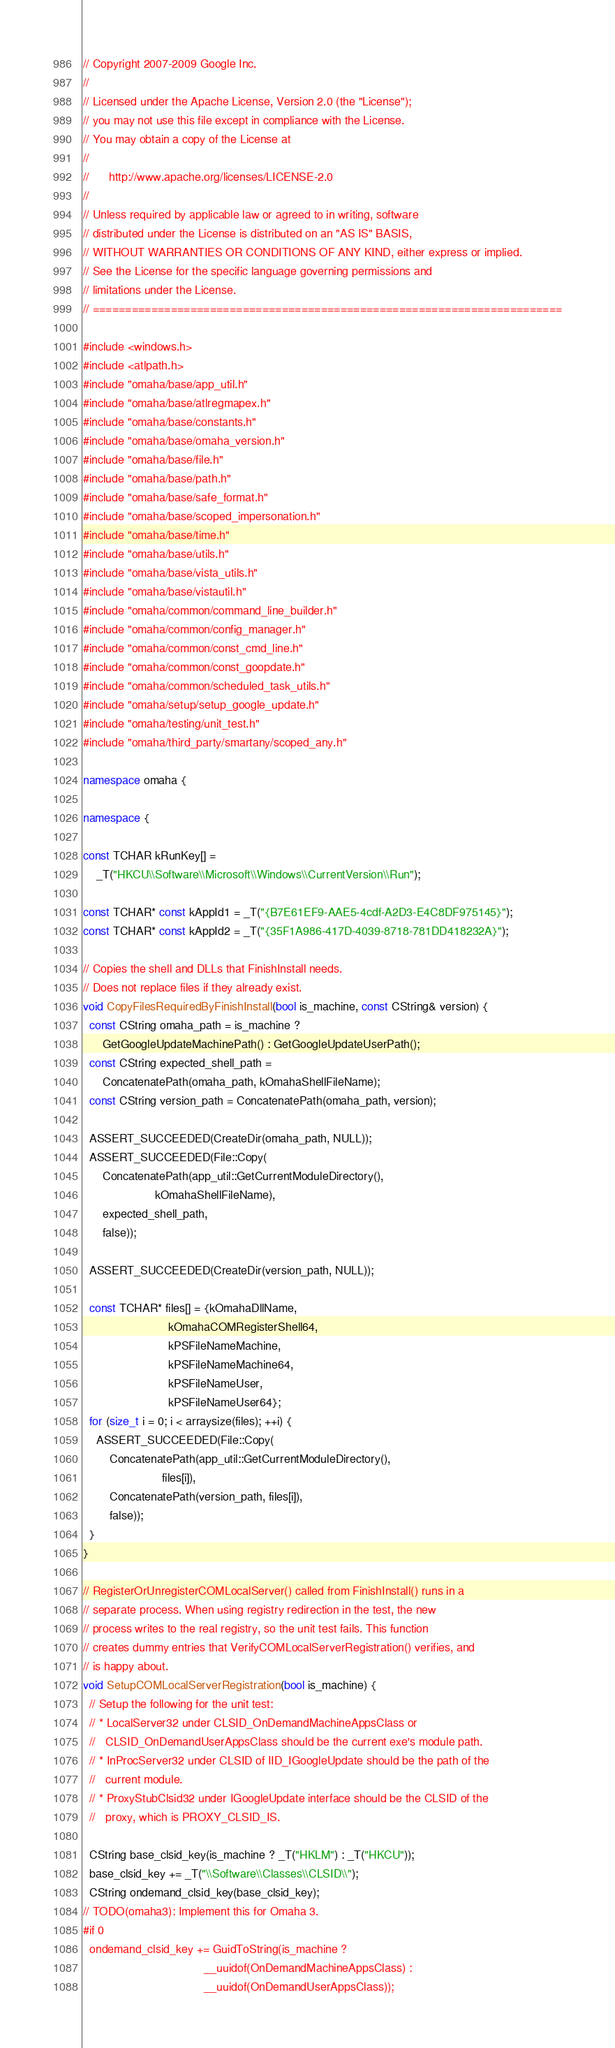<code> <loc_0><loc_0><loc_500><loc_500><_C++_>// Copyright 2007-2009 Google Inc.
//
// Licensed under the Apache License, Version 2.0 (the "License");
// you may not use this file except in compliance with the License.
// You may obtain a copy of the License at
//
//      http://www.apache.org/licenses/LICENSE-2.0
//
// Unless required by applicable law or agreed to in writing, software
// distributed under the License is distributed on an "AS IS" BASIS,
// WITHOUT WARRANTIES OR CONDITIONS OF ANY KIND, either express or implied.
// See the License for the specific language governing permissions and
// limitations under the License.
// ========================================================================

#include <windows.h>
#include <atlpath.h>
#include "omaha/base/app_util.h"
#include "omaha/base/atlregmapex.h"
#include "omaha/base/constants.h"
#include "omaha/base/omaha_version.h"
#include "omaha/base/file.h"
#include "omaha/base/path.h"
#include "omaha/base/safe_format.h"
#include "omaha/base/scoped_impersonation.h"
#include "omaha/base/time.h"
#include "omaha/base/utils.h"
#include "omaha/base/vista_utils.h"
#include "omaha/base/vistautil.h"
#include "omaha/common/command_line_builder.h"
#include "omaha/common/config_manager.h"
#include "omaha/common/const_cmd_line.h"
#include "omaha/common/const_goopdate.h"
#include "omaha/common/scheduled_task_utils.h"
#include "omaha/setup/setup_google_update.h"
#include "omaha/testing/unit_test.h"
#include "omaha/third_party/smartany/scoped_any.h"

namespace omaha {

namespace {

const TCHAR kRunKey[] =
    _T("HKCU\\Software\\Microsoft\\Windows\\CurrentVersion\\Run");

const TCHAR* const kAppId1 = _T("{B7E61EF9-AAE5-4cdf-A2D3-E4C8DF975145}");
const TCHAR* const kAppId2 = _T("{35F1A986-417D-4039-8718-781DD418232A}");

// Copies the shell and DLLs that FinishInstall needs.
// Does not replace files if they already exist.
void CopyFilesRequiredByFinishInstall(bool is_machine, const CString& version) {
  const CString omaha_path = is_machine ?
      GetGoogleUpdateMachinePath() : GetGoogleUpdateUserPath();
  const CString expected_shell_path =
      ConcatenatePath(omaha_path, kOmahaShellFileName);
  const CString version_path = ConcatenatePath(omaha_path, version);

  ASSERT_SUCCEEDED(CreateDir(omaha_path, NULL));
  ASSERT_SUCCEEDED(File::Copy(
      ConcatenatePath(app_util::GetCurrentModuleDirectory(),
                      kOmahaShellFileName),
      expected_shell_path,
      false));

  ASSERT_SUCCEEDED(CreateDir(version_path, NULL));

  const TCHAR* files[] = {kOmahaDllName,
                          kOmahaCOMRegisterShell64,
                          kPSFileNameMachine,
                          kPSFileNameMachine64,
                          kPSFileNameUser,
                          kPSFileNameUser64};
  for (size_t i = 0; i < arraysize(files); ++i) {
    ASSERT_SUCCEEDED(File::Copy(
        ConcatenatePath(app_util::GetCurrentModuleDirectory(),
                        files[i]),
        ConcatenatePath(version_path, files[i]),
        false));
  }
}

// RegisterOrUnregisterCOMLocalServer() called from FinishInstall() runs in a
// separate process. When using registry redirection in the test, the new
// process writes to the real registry, so the unit test fails. This function
// creates dummy entries that VerifyCOMLocalServerRegistration() verifies, and
// is happy about.
void SetupCOMLocalServerRegistration(bool is_machine) {
  // Setup the following for the unit test:
  // * LocalServer32 under CLSID_OnDemandMachineAppsClass or
  //   CLSID_OnDemandUserAppsClass should be the current exe's module path.
  // * InProcServer32 under CLSID of IID_IGoogleUpdate should be the path of the
  //   current module.
  // * ProxyStubClsid32 under IGoogleUpdate interface should be the CLSID of the
  //   proxy, which is PROXY_CLSID_IS.

  CString base_clsid_key(is_machine ? _T("HKLM") : _T("HKCU"));
  base_clsid_key += _T("\\Software\\Classes\\CLSID\\");
  CString ondemand_clsid_key(base_clsid_key);
// TODO(omaha3): Implement this for Omaha 3.
#if 0
  ondemand_clsid_key += GuidToString(is_machine ?
                                     __uuidof(OnDemandMachineAppsClass) :
                                     __uuidof(OnDemandUserAppsClass));</code> 